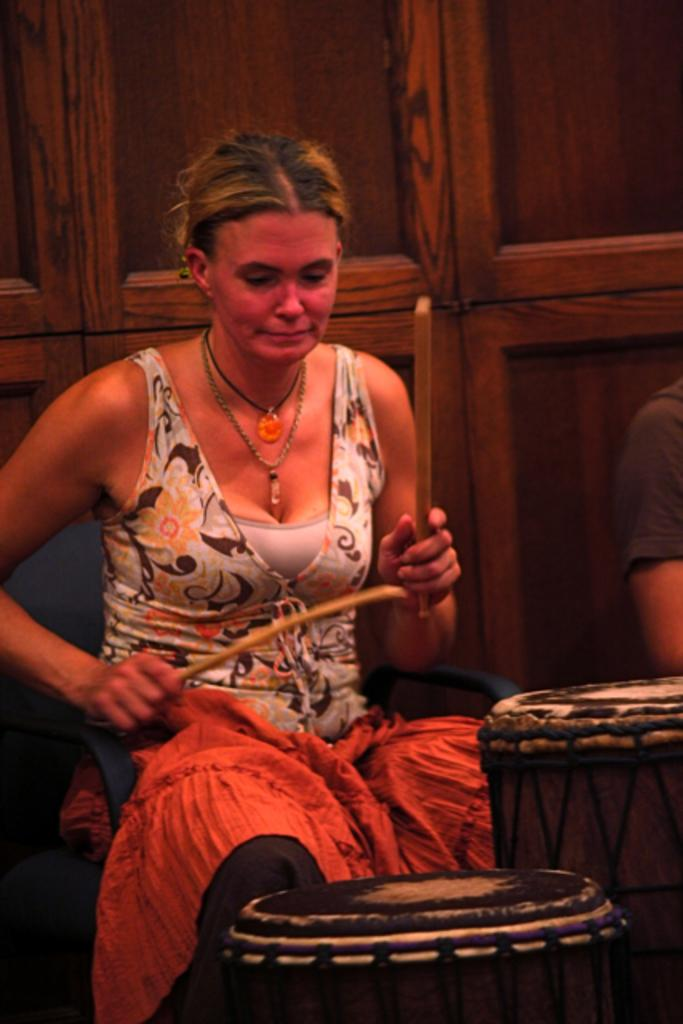What is the woman in the image doing? The woman is beating drums. Can you describe the person beside the woman? Unfortunately, the provided facts do not give any information about the person beside the woman. What can be seen in the background of the image? There is a wooden wall in the background of the image. What type of fork can be seen in the woman's hand in the image? There is no fork present in the image; the woman is beating drums with her hands. Where is the garden located in the image? There is no garden present in the image; the background features a wooden wall. 